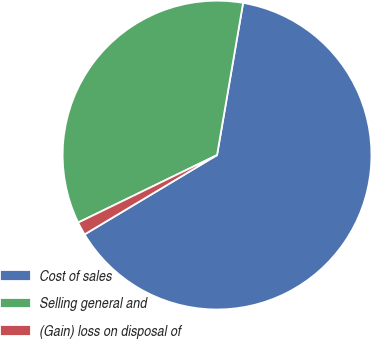Convert chart to OTSL. <chart><loc_0><loc_0><loc_500><loc_500><pie_chart><fcel>Cost of sales<fcel>Selling general and<fcel>(Gain) loss on disposal of<nl><fcel>63.71%<fcel>34.9%<fcel>1.39%<nl></chart> 